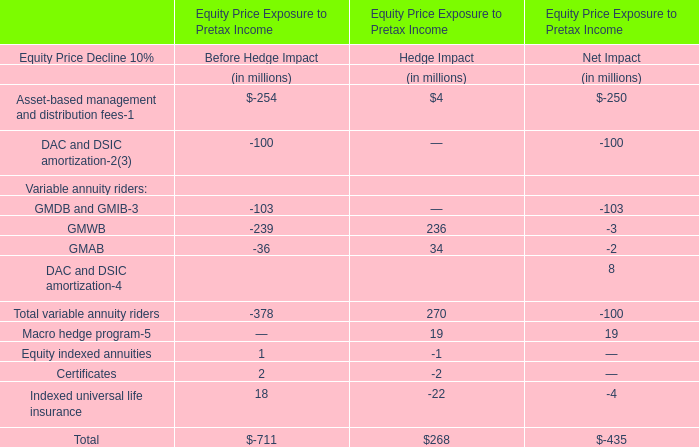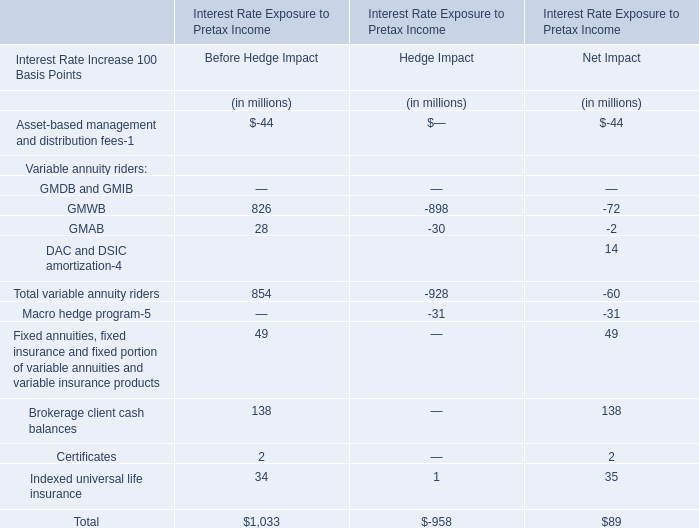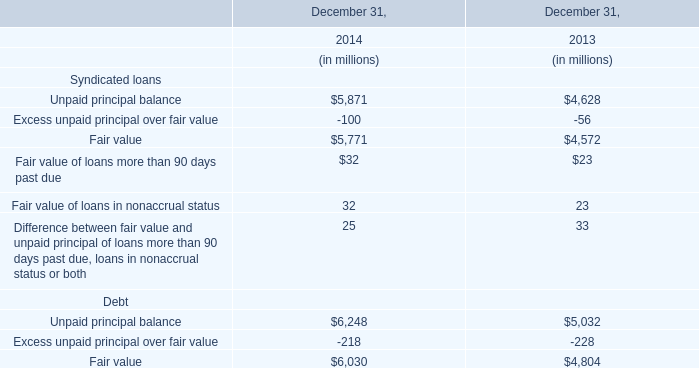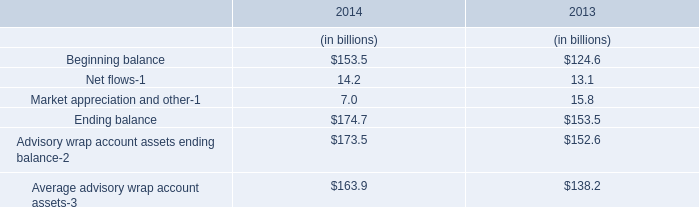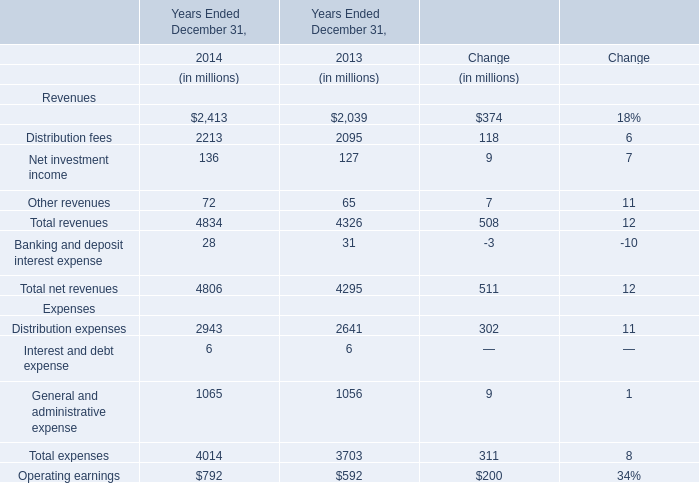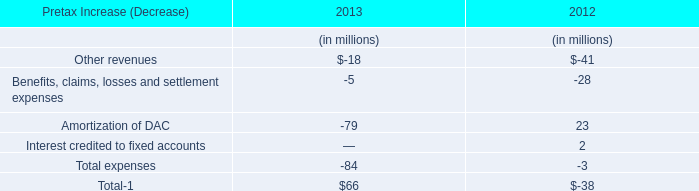In the year with lowest amount of Banking and deposit interest expense, what's the increasing rate of Total revenues? 
Computations: ((4834 - 4326) / 4326)
Answer: 0.11743. 